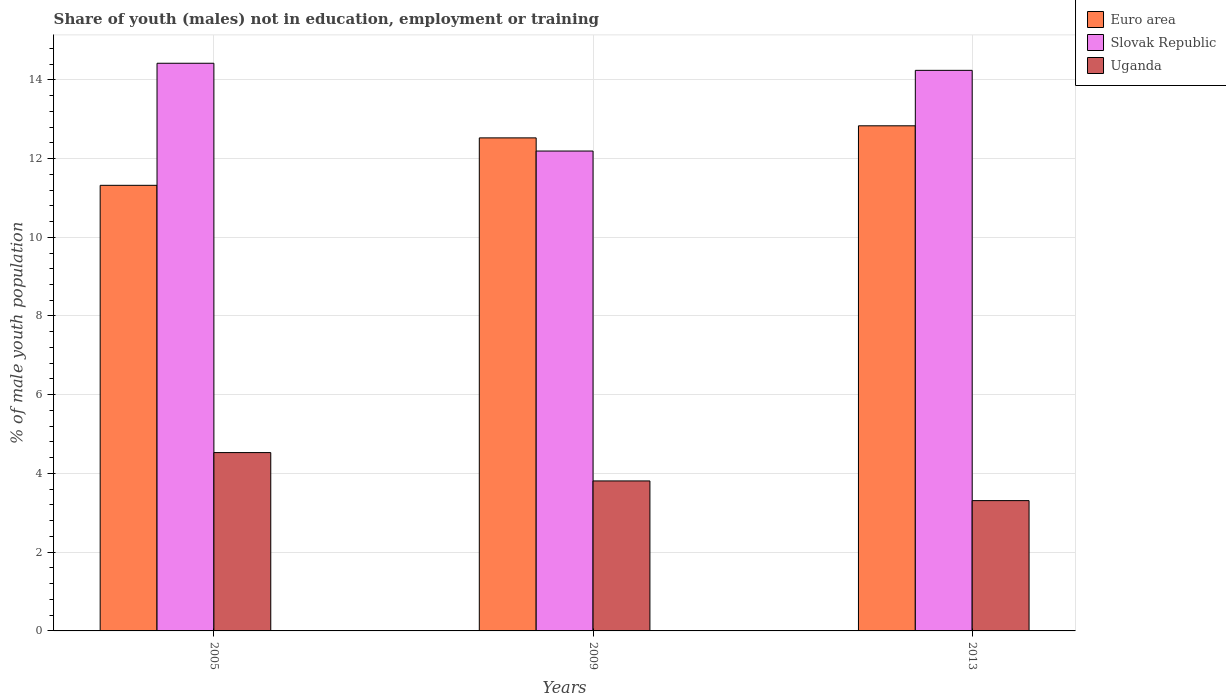How many different coloured bars are there?
Your response must be concise. 3. How many groups of bars are there?
Give a very brief answer. 3. Are the number of bars per tick equal to the number of legend labels?
Provide a short and direct response. Yes. How many bars are there on the 2nd tick from the left?
Ensure brevity in your answer.  3. How many bars are there on the 2nd tick from the right?
Your answer should be very brief. 3. In how many cases, is the number of bars for a given year not equal to the number of legend labels?
Ensure brevity in your answer.  0. What is the percentage of unemployed males population in in Uganda in 2013?
Your response must be concise. 3.31. Across all years, what is the maximum percentage of unemployed males population in in Uganda?
Your response must be concise. 4.53. Across all years, what is the minimum percentage of unemployed males population in in Slovak Republic?
Offer a terse response. 12.19. In which year was the percentage of unemployed males population in in Uganda maximum?
Keep it short and to the point. 2005. What is the total percentage of unemployed males population in in Uganda in the graph?
Provide a short and direct response. 11.65. What is the difference between the percentage of unemployed males population in in Slovak Republic in 2005 and that in 2013?
Provide a short and direct response. 0.18. What is the difference between the percentage of unemployed males population in in Uganda in 2005 and the percentage of unemployed males population in in Slovak Republic in 2013?
Provide a short and direct response. -9.71. What is the average percentage of unemployed males population in in Euro area per year?
Offer a very short reply. 12.23. In the year 2005, what is the difference between the percentage of unemployed males population in in Euro area and percentage of unemployed males population in in Slovak Republic?
Offer a very short reply. -3.1. What is the ratio of the percentage of unemployed males population in in Uganda in 2009 to that in 2013?
Provide a short and direct response. 1.15. Is the percentage of unemployed males population in in Slovak Republic in 2005 less than that in 2013?
Make the answer very short. No. Is the difference between the percentage of unemployed males population in in Euro area in 2009 and 2013 greater than the difference between the percentage of unemployed males population in in Slovak Republic in 2009 and 2013?
Your answer should be very brief. Yes. What is the difference between the highest and the second highest percentage of unemployed males population in in Euro area?
Give a very brief answer. 0.31. What is the difference between the highest and the lowest percentage of unemployed males population in in Uganda?
Your answer should be compact. 1.22. Is the sum of the percentage of unemployed males population in in Uganda in 2005 and 2013 greater than the maximum percentage of unemployed males population in in Euro area across all years?
Offer a terse response. No. What does the 2nd bar from the left in 2013 represents?
Provide a succinct answer. Slovak Republic. What does the 1st bar from the right in 2013 represents?
Give a very brief answer. Uganda. Is it the case that in every year, the sum of the percentage of unemployed males population in in Slovak Republic and percentage of unemployed males population in in Uganda is greater than the percentage of unemployed males population in in Euro area?
Your answer should be very brief. Yes. How many bars are there?
Your answer should be very brief. 9. Are all the bars in the graph horizontal?
Keep it short and to the point. No. How many years are there in the graph?
Provide a succinct answer. 3. What is the difference between two consecutive major ticks on the Y-axis?
Offer a very short reply. 2. Are the values on the major ticks of Y-axis written in scientific E-notation?
Ensure brevity in your answer.  No. Where does the legend appear in the graph?
Give a very brief answer. Top right. How many legend labels are there?
Offer a very short reply. 3. How are the legend labels stacked?
Your answer should be compact. Vertical. What is the title of the graph?
Ensure brevity in your answer.  Share of youth (males) not in education, employment or training. What is the label or title of the X-axis?
Offer a terse response. Years. What is the label or title of the Y-axis?
Offer a terse response. % of male youth population. What is the % of male youth population in Euro area in 2005?
Offer a terse response. 11.32. What is the % of male youth population of Slovak Republic in 2005?
Offer a terse response. 14.42. What is the % of male youth population in Uganda in 2005?
Your answer should be compact. 4.53. What is the % of male youth population of Euro area in 2009?
Offer a terse response. 12.52. What is the % of male youth population of Slovak Republic in 2009?
Give a very brief answer. 12.19. What is the % of male youth population of Uganda in 2009?
Offer a terse response. 3.81. What is the % of male youth population of Euro area in 2013?
Offer a very short reply. 12.83. What is the % of male youth population of Slovak Republic in 2013?
Offer a terse response. 14.24. What is the % of male youth population of Uganda in 2013?
Your response must be concise. 3.31. Across all years, what is the maximum % of male youth population in Euro area?
Provide a succinct answer. 12.83. Across all years, what is the maximum % of male youth population of Slovak Republic?
Provide a succinct answer. 14.42. Across all years, what is the maximum % of male youth population of Uganda?
Give a very brief answer. 4.53. Across all years, what is the minimum % of male youth population in Euro area?
Offer a terse response. 11.32. Across all years, what is the minimum % of male youth population in Slovak Republic?
Your response must be concise. 12.19. Across all years, what is the minimum % of male youth population in Uganda?
Your response must be concise. 3.31. What is the total % of male youth population of Euro area in the graph?
Your answer should be compact. 36.67. What is the total % of male youth population in Slovak Republic in the graph?
Your answer should be very brief. 40.85. What is the total % of male youth population in Uganda in the graph?
Make the answer very short. 11.65. What is the difference between the % of male youth population in Euro area in 2005 and that in 2009?
Your answer should be compact. -1.21. What is the difference between the % of male youth population of Slovak Republic in 2005 and that in 2009?
Give a very brief answer. 2.23. What is the difference between the % of male youth population of Uganda in 2005 and that in 2009?
Provide a succinct answer. 0.72. What is the difference between the % of male youth population of Euro area in 2005 and that in 2013?
Ensure brevity in your answer.  -1.51. What is the difference between the % of male youth population in Slovak Republic in 2005 and that in 2013?
Give a very brief answer. 0.18. What is the difference between the % of male youth population in Uganda in 2005 and that in 2013?
Your response must be concise. 1.22. What is the difference between the % of male youth population in Euro area in 2009 and that in 2013?
Keep it short and to the point. -0.31. What is the difference between the % of male youth population in Slovak Republic in 2009 and that in 2013?
Ensure brevity in your answer.  -2.05. What is the difference between the % of male youth population of Uganda in 2009 and that in 2013?
Your response must be concise. 0.5. What is the difference between the % of male youth population in Euro area in 2005 and the % of male youth population in Slovak Republic in 2009?
Provide a succinct answer. -0.87. What is the difference between the % of male youth population of Euro area in 2005 and the % of male youth population of Uganda in 2009?
Your response must be concise. 7.51. What is the difference between the % of male youth population of Slovak Republic in 2005 and the % of male youth population of Uganda in 2009?
Provide a short and direct response. 10.61. What is the difference between the % of male youth population in Euro area in 2005 and the % of male youth population in Slovak Republic in 2013?
Your answer should be compact. -2.92. What is the difference between the % of male youth population in Euro area in 2005 and the % of male youth population in Uganda in 2013?
Give a very brief answer. 8.01. What is the difference between the % of male youth population of Slovak Republic in 2005 and the % of male youth population of Uganda in 2013?
Your answer should be very brief. 11.11. What is the difference between the % of male youth population in Euro area in 2009 and the % of male youth population in Slovak Republic in 2013?
Keep it short and to the point. -1.72. What is the difference between the % of male youth population in Euro area in 2009 and the % of male youth population in Uganda in 2013?
Your answer should be very brief. 9.21. What is the difference between the % of male youth population in Slovak Republic in 2009 and the % of male youth population in Uganda in 2013?
Your answer should be very brief. 8.88. What is the average % of male youth population in Euro area per year?
Provide a succinct answer. 12.22. What is the average % of male youth population in Slovak Republic per year?
Give a very brief answer. 13.62. What is the average % of male youth population of Uganda per year?
Make the answer very short. 3.88. In the year 2005, what is the difference between the % of male youth population of Euro area and % of male youth population of Slovak Republic?
Offer a terse response. -3.1. In the year 2005, what is the difference between the % of male youth population of Euro area and % of male youth population of Uganda?
Make the answer very short. 6.79. In the year 2005, what is the difference between the % of male youth population in Slovak Republic and % of male youth population in Uganda?
Give a very brief answer. 9.89. In the year 2009, what is the difference between the % of male youth population of Euro area and % of male youth population of Slovak Republic?
Give a very brief answer. 0.33. In the year 2009, what is the difference between the % of male youth population in Euro area and % of male youth population in Uganda?
Your answer should be very brief. 8.71. In the year 2009, what is the difference between the % of male youth population of Slovak Republic and % of male youth population of Uganda?
Make the answer very short. 8.38. In the year 2013, what is the difference between the % of male youth population in Euro area and % of male youth population in Slovak Republic?
Offer a terse response. -1.41. In the year 2013, what is the difference between the % of male youth population in Euro area and % of male youth population in Uganda?
Ensure brevity in your answer.  9.52. In the year 2013, what is the difference between the % of male youth population of Slovak Republic and % of male youth population of Uganda?
Offer a terse response. 10.93. What is the ratio of the % of male youth population of Euro area in 2005 to that in 2009?
Keep it short and to the point. 0.9. What is the ratio of the % of male youth population in Slovak Republic in 2005 to that in 2009?
Keep it short and to the point. 1.18. What is the ratio of the % of male youth population of Uganda in 2005 to that in 2009?
Ensure brevity in your answer.  1.19. What is the ratio of the % of male youth population of Euro area in 2005 to that in 2013?
Offer a terse response. 0.88. What is the ratio of the % of male youth population in Slovak Republic in 2005 to that in 2013?
Your answer should be very brief. 1.01. What is the ratio of the % of male youth population of Uganda in 2005 to that in 2013?
Keep it short and to the point. 1.37. What is the ratio of the % of male youth population in Euro area in 2009 to that in 2013?
Provide a succinct answer. 0.98. What is the ratio of the % of male youth population in Slovak Republic in 2009 to that in 2013?
Offer a terse response. 0.86. What is the ratio of the % of male youth population of Uganda in 2009 to that in 2013?
Your answer should be compact. 1.15. What is the difference between the highest and the second highest % of male youth population in Euro area?
Offer a terse response. 0.31. What is the difference between the highest and the second highest % of male youth population in Slovak Republic?
Give a very brief answer. 0.18. What is the difference between the highest and the second highest % of male youth population in Uganda?
Keep it short and to the point. 0.72. What is the difference between the highest and the lowest % of male youth population of Euro area?
Your response must be concise. 1.51. What is the difference between the highest and the lowest % of male youth population in Slovak Republic?
Provide a succinct answer. 2.23. What is the difference between the highest and the lowest % of male youth population of Uganda?
Offer a very short reply. 1.22. 